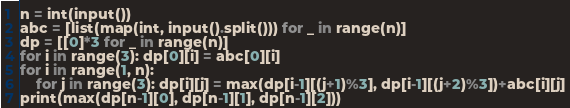Convert code to text. <code><loc_0><loc_0><loc_500><loc_500><_Python_>n = int(input())
abc = [list(map(int, input().split())) for _ in range(n)]
dp = [[0]*3 for _ in range(n)]
for i in range(3): dp[0][i] = abc[0][i]
for i in range(1, n):
    for j in range(3): dp[i][j] = max(dp[i-1][(j+1)%3], dp[i-1][(j+2)%3])+abc[i][j]
print(max(dp[n-1][0], dp[n-1][1], dp[n-1][2]))</code> 